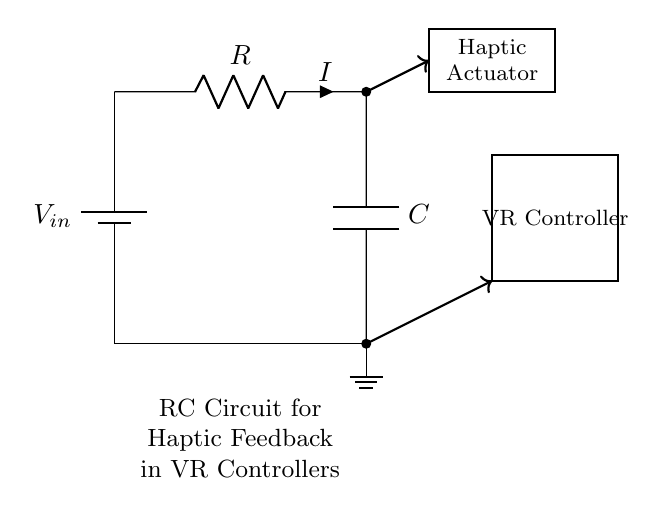What is the power supply voltage in the circuit? The circuit shows a battery labeled as \( V_{in} \) that serves as the power supply, but the specific value is not provided in the diagram. Therefore, we can only identify it as an input voltage.
Answer: Vin What is the role of the resistor in this circuit? The resistor is labeled \( R \) and is connected in series with the capacitor. Its main function is to limit the current flowing into the capacitor, thereby influencing the charging time and the discharge behavior of the RC circuit.
Answer: Limit current What is the haptic actuator in the circuit's context? The haptic actuator is represented as a rectangle in the diagram, indicating it is a component responsible for providing feedback. In the context of a VR controller, its role is to generate physical sensations based on user interactions or feedback from the virtual environment.
Answer: Feedback device Which component is responsible for energy storage in the circuit? The capacitor is labeled \( C \) and is connected in parallel with the load (the VR controller). It stores electrical energy and releases it when needed, influencing the performance and timing of the haptic feedback.
Answer: Capacitor What type of circuit configuration is depicted? This circuit consists of a basic Resistor-Capacitor (RC) configuration where the resistor and capacitor are connected in series with respect to the input voltage, creating a low-pass filter effect optimal for controlling haptic feedback.
Answer: RC circuit 